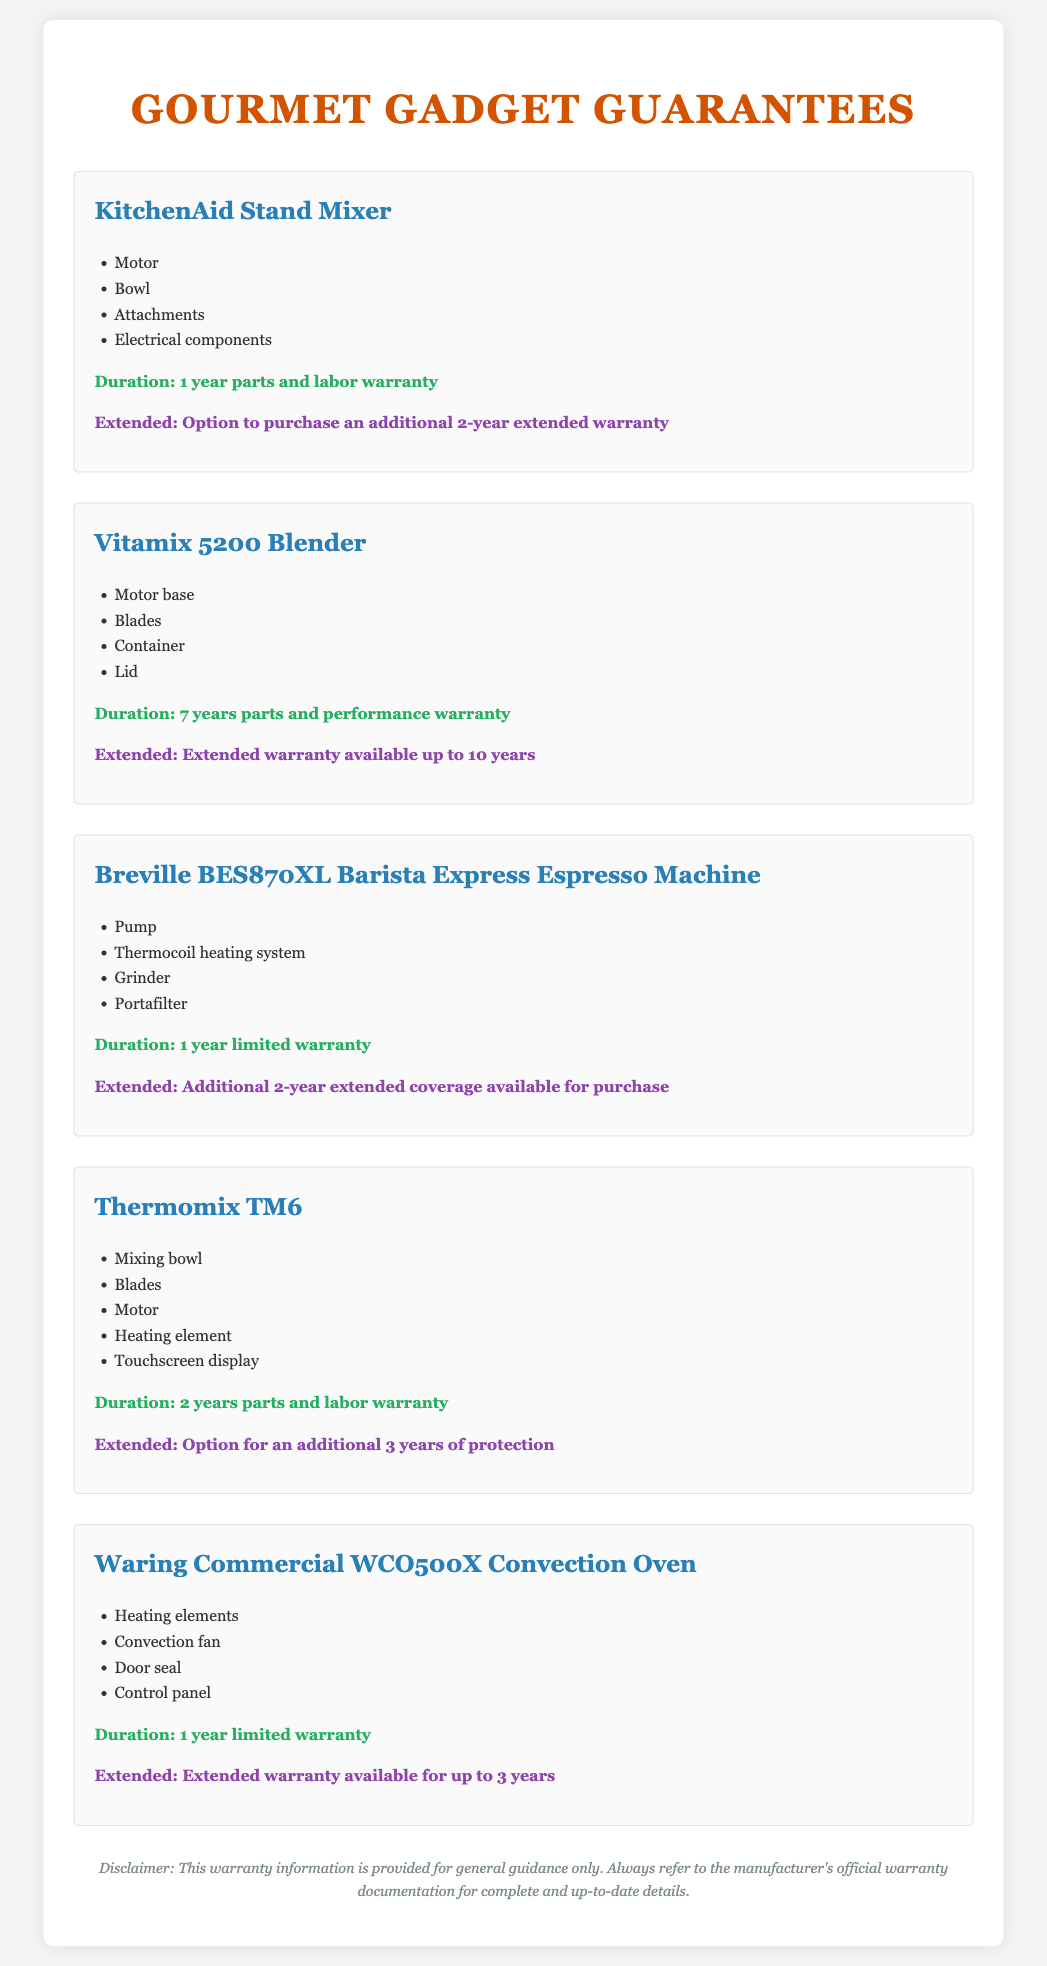What is the warranty duration for the KitchenAid Stand Mixer? The duration for the KitchenAid Stand Mixer is specified in the document as a 1 year parts and labor warranty.
Answer: 1 year parts and labor warranty How long is the warranty for the Vitamix 5200 Blender? The warranty duration stated for the Vitamix 5200 Blender is 7 years parts and performance warranty.
Answer: 7 years parts and performance warranty What additional warranty option is available for the Thermomix TM6? The document mentions an option for an additional 3 years of protection for the Thermomix TM6.
Answer: Additional 3 years of protection Which component is covered under the warranty for the Breville BES870XL Espresso Machine? The document lists specific components covered, and one of them is the grinder.
Answer: Grinder How many total years of warranty coverage can you have for the Waring Commercial WCO500X Oven? The total possible warrantable years, including the extended warranty for the Waring Commercial WCO500X Oven, amounts to 4 years (1 year + 3 years).
Answer: 4 years What is the duration of the warranty for KitchenAid attachments? According to the document, the attachments of the KitchenAid Stand Mixer are included in the 1 year warranty duration.
Answer: 1 year Is an extended warranty available for the Vitamix 5200 Blender? The document confirms that an extended warranty is available up to 10 years for the Vitamix 5200 Blender.
Answer: Extended warranty available up to 10 years What kind of warranty is provided for the Breville Espresso Machine? The warranty type provided for the Breville BES870XL is described as a 1 year limited warranty.
Answer: 1 year limited warranty 